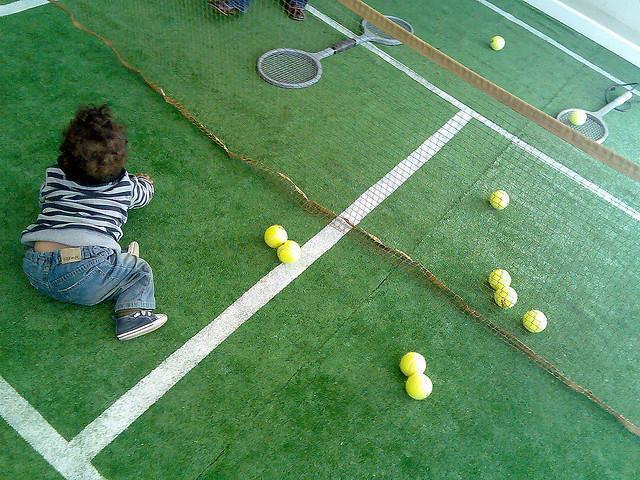How many cars are in this scene?
Give a very brief answer. 0. 